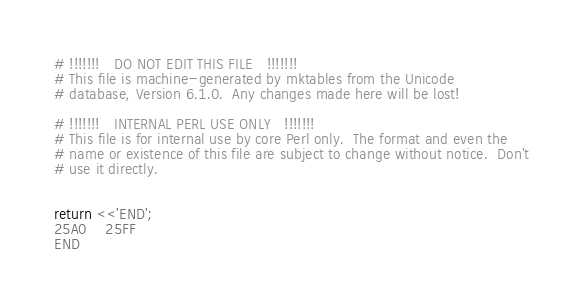Convert code to text. <code><loc_0><loc_0><loc_500><loc_500><_Perl_># !!!!!!!   DO NOT EDIT THIS FILE   !!!!!!!
# This file is machine-generated by mktables from the Unicode
# database, Version 6.1.0.  Any changes made here will be lost!

# !!!!!!!   INTERNAL PERL USE ONLY   !!!!!!!
# This file is for internal use by core Perl only.  The format and even the
# name or existence of this file are subject to change without notice.  Don't
# use it directly.


return <<'END';
25A0	25FF
END
</code> 